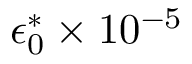Convert formula to latex. <formula><loc_0><loc_0><loc_500><loc_500>\epsilon _ { 0 } ^ { * } \times 1 0 ^ { - 5 }</formula> 